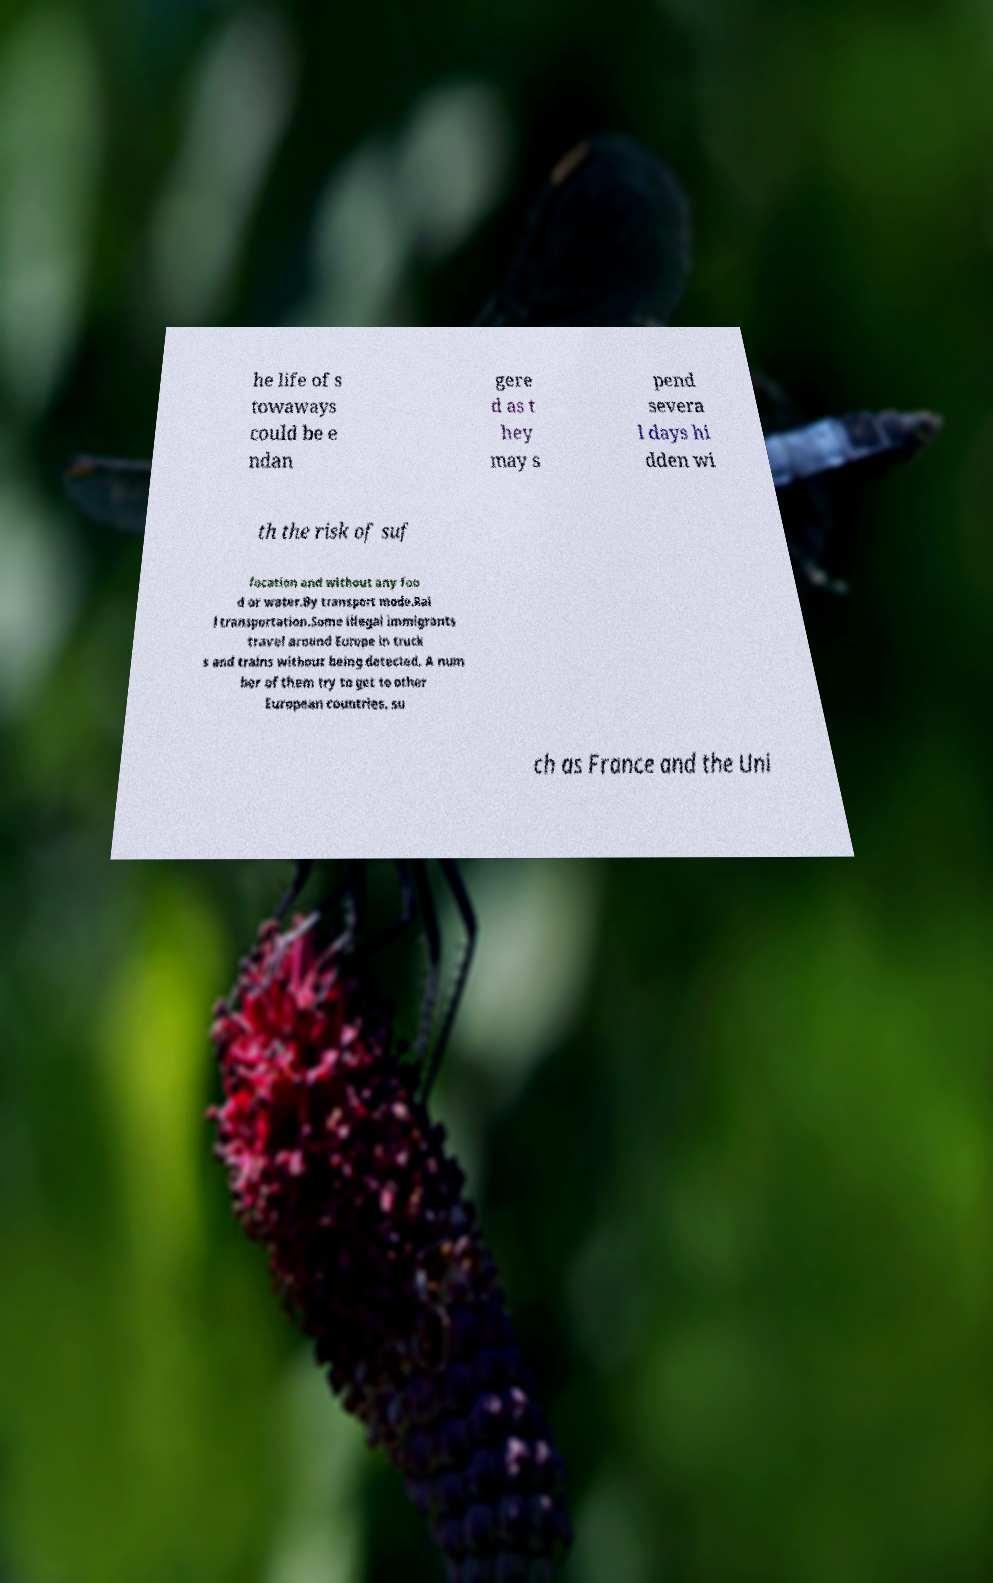There's text embedded in this image that I need extracted. Can you transcribe it verbatim? he life of s towaways could be e ndan gere d as t hey may s pend severa l days hi dden wi th the risk of suf focation and without any foo d or water.By transport mode.Rai l transportation.Some illegal immigrants travel around Europe in truck s and trains without being detected. A num ber of them try to get to other European countries, su ch as France and the Uni 